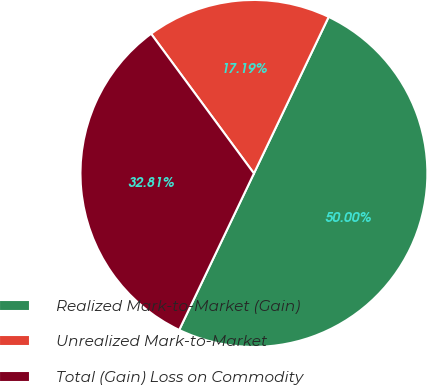Convert chart. <chart><loc_0><loc_0><loc_500><loc_500><pie_chart><fcel>Realized Mark-to-Market (Gain)<fcel>Unrealized Mark-to-Market<fcel>Total (Gain) Loss on Commodity<nl><fcel>50.0%<fcel>17.19%<fcel>32.81%<nl></chart> 